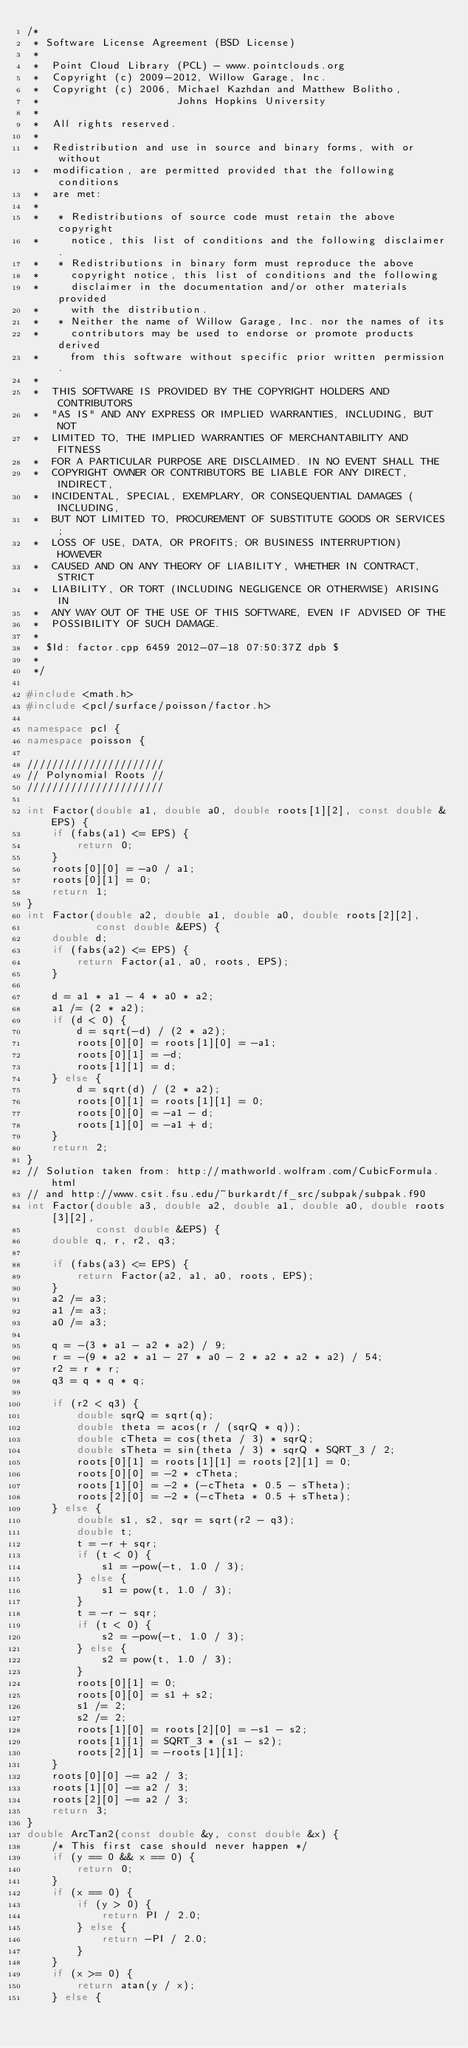<code> <loc_0><loc_0><loc_500><loc_500><_C++_>/*
 * Software License Agreement (BSD License)
 *
 *  Point Cloud Library (PCL) - www.pointclouds.org
 *  Copyright (c) 2009-2012, Willow Garage, Inc.
 *  Copyright (c) 2006, Michael Kazhdan and Matthew Bolitho,
 *                      Johns Hopkins University
 *
 *  All rights reserved.
 *
 *  Redistribution and use in source and binary forms, with or without
 *  modification, are permitted provided that the following conditions
 *  are met:
 *
 *   * Redistributions of source code must retain the above copyright
 *     notice, this list of conditions and the following disclaimer.
 *   * Redistributions in binary form must reproduce the above
 *     copyright notice, this list of conditions and the following
 *     disclaimer in the documentation and/or other materials provided
 *     with the distribution.
 *   * Neither the name of Willow Garage, Inc. nor the names of its
 *     contributors may be used to endorse or promote products derived
 *     from this software without specific prior written permission.
 *
 *  THIS SOFTWARE IS PROVIDED BY THE COPYRIGHT HOLDERS AND CONTRIBUTORS
 *  "AS IS" AND ANY EXPRESS OR IMPLIED WARRANTIES, INCLUDING, BUT NOT
 *  LIMITED TO, THE IMPLIED WARRANTIES OF MERCHANTABILITY AND FITNESS
 *  FOR A PARTICULAR PURPOSE ARE DISCLAIMED. IN NO EVENT SHALL THE
 *  COPYRIGHT OWNER OR CONTRIBUTORS BE LIABLE FOR ANY DIRECT, INDIRECT,
 *  INCIDENTAL, SPECIAL, EXEMPLARY, OR CONSEQUENTIAL DAMAGES (INCLUDING,
 *  BUT NOT LIMITED TO, PROCUREMENT OF SUBSTITUTE GOODS OR SERVICES;
 *  LOSS OF USE, DATA, OR PROFITS; OR BUSINESS INTERRUPTION) HOWEVER
 *  CAUSED AND ON ANY THEORY OF LIABILITY, WHETHER IN CONTRACT, STRICT
 *  LIABILITY, OR TORT (INCLUDING NEGLIGENCE OR OTHERWISE) ARISING IN
 *  ANY WAY OUT OF THE USE OF THIS SOFTWARE, EVEN IF ADVISED OF THE
 *  POSSIBILITY OF SUCH DAMAGE.
 *
 * $Id: factor.cpp 6459 2012-07-18 07:50:37Z dpb $
 *
 */

#include <math.h>
#include <pcl/surface/poisson/factor.h>

namespace pcl {
namespace poisson {

//////////////////////
// Polynomial Roots //
//////////////////////

int Factor(double a1, double a0, double roots[1][2], const double &EPS) {
    if (fabs(a1) <= EPS) {
        return 0;
    }
    roots[0][0] = -a0 / a1;
    roots[0][1] = 0;
    return 1;
}
int Factor(double a2, double a1, double a0, double roots[2][2],
           const double &EPS) {
    double d;
    if (fabs(a2) <= EPS) {
        return Factor(a1, a0, roots, EPS);
    }

    d = a1 * a1 - 4 * a0 * a2;
    a1 /= (2 * a2);
    if (d < 0) {
        d = sqrt(-d) / (2 * a2);
        roots[0][0] = roots[1][0] = -a1;
        roots[0][1] = -d;
        roots[1][1] = d;
    } else {
        d = sqrt(d) / (2 * a2);
        roots[0][1] = roots[1][1] = 0;
        roots[0][0] = -a1 - d;
        roots[1][0] = -a1 + d;
    }
    return 2;
}
// Solution taken from: http://mathworld.wolfram.com/CubicFormula.html
// and http://www.csit.fsu.edu/~burkardt/f_src/subpak/subpak.f90
int Factor(double a3, double a2, double a1, double a0, double roots[3][2],
           const double &EPS) {
    double q, r, r2, q3;

    if (fabs(a3) <= EPS) {
        return Factor(a2, a1, a0, roots, EPS);
    }
    a2 /= a3;
    a1 /= a3;
    a0 /= a3;

    q = -(3 * a1 - a2 * a2) / 9;
    r = -(9 * a2 * a1 - 27 * a0 - 2 * a2 * a2 * a2) / 54;
    r2 = r * r;
    q3 = q * q * q;

    if (r2 < q3) {
        double sqrQ = sqrt(q);
        double theta = acos(r / (sqrQ * q));
        double cTheta = cos(theta / 3) * sqrQ;
        double sTheta = sin(theta / 3) * sqrQ * SQRT_3 / 2;
        roots[0][1] = roots[1][1] = roots[2][1] = 0;
        roots[0][0] = -2 * cTheta;
        roots[1][0] = -2 * (-cTheta * 0.5 - sTheta);
        roots[2][0] = -2 * (-cTheta * 0.5 + sTheta);
    } else {
        double s1, s2, sqr = sqrt(r2 - q3);
        double t;
        t = -r + sqr;
        if (t < 0) {
            s1 = -pow(-t, 1.0 / 3);
        } else {
            s1 = pow(t, 1.0 / 3);
        }
        t = -r - sqr;
        if (t < 0) {
            s2 = -pow(-t, 1.0 / 3);
        } else {
            s2 = pow(t, 1.0 / 3);
        }
        roots[0][1] = 0;
        roots[0][0] = s1 + s2;
        s1 /= 2;
        s2 /= 2;
        roots[1][0] = roots[2][0] = -s1 - s2;
        roots[1][1] = SQRT_3 * (s1 - s2);
        roots[2][1] = -roots[1][1];
    }
    roots[0][0] -= a2 / 3;
    roots[1][0] -= a2 / 3;
    roots[2][0] -= a2 / 3;
    return 3;
}
double ArcTan2(const double &y, const double &x) {
    /* This first case should never happen */
    if (y == 0 && x == 0) {
        return 0;
    }
    if (x == 0) {
        if (y > 0) {
            return PI / 2.0;
        } else {
            return -PI / 2.0;
        }
    }
    if (x >= 0) {
        return atan(y / x);
    } else {</code> 